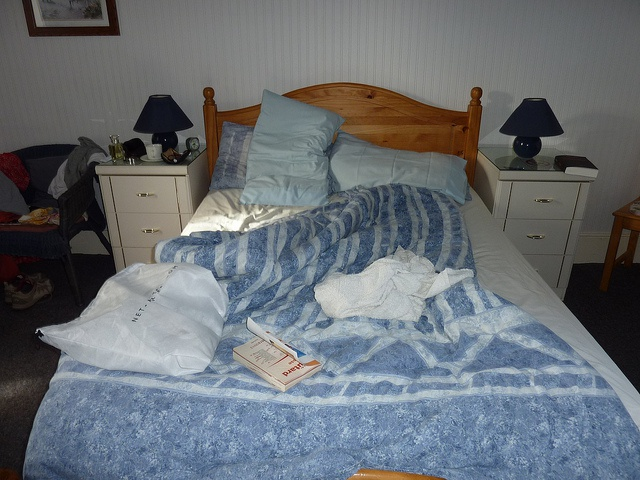Describe the objects in this image and their specific colors. I can see bed in gray and darkgray tones, chair in gray and black tones, book in gray, darkgray, and lightgray tones, book in gray and black tones, and clock in gray, black, and darkgreen tones in this image. 